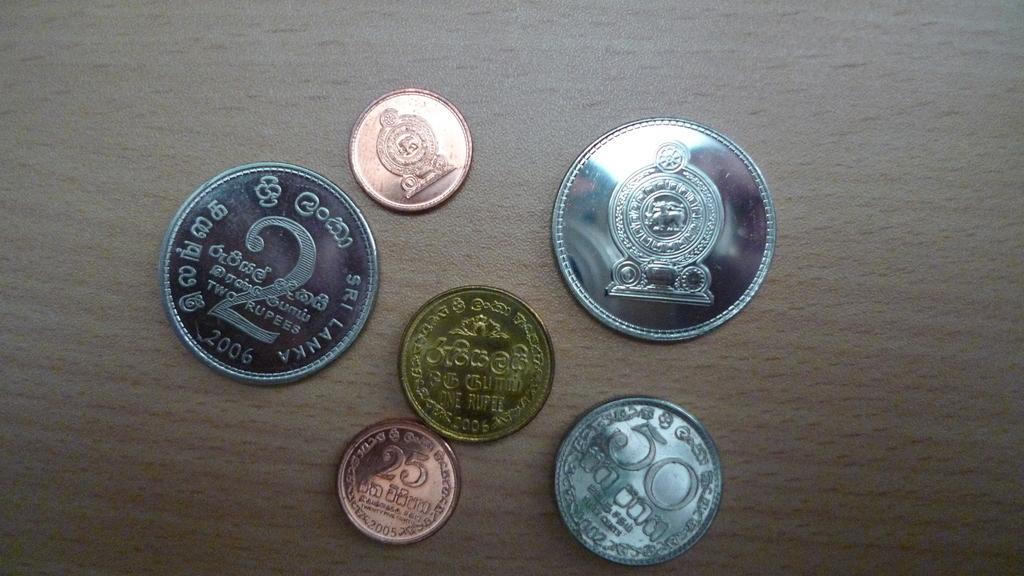Which country do these coins come from?
Provide a short and direct response. Sri lanka. 